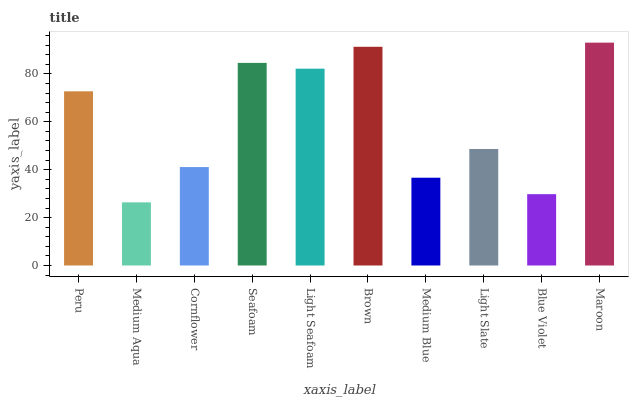Is Medium Aqua the minimum?
Answer yes or no. Yes. Is Maroon the maximum?
Answer yes or no. Yes. Is Cornflower the minimum?
Answer yes or no. No. Is Cornflower the maximum?
Answer yes or no. No. Is Cornflower greater than Medium Aqua?
Answer yes or no. Yes. Is Medium Aqua less than Cornflower?
Answer yes or no. Yes. Is Medium Aqua greater than Cornflower?
Answer yes or no. No. Is Cornflower less than Medium Aqua?
Answer yes or no. No. Is Peru the high median?
Answer yes or no. Yes. Is Light Slate the low median?
Answer yes or no. Yes. Is Light Seafoam the high median?
Answer yes or no. No. Is Medium Aqua the low median?
Answer yes or no. No. 